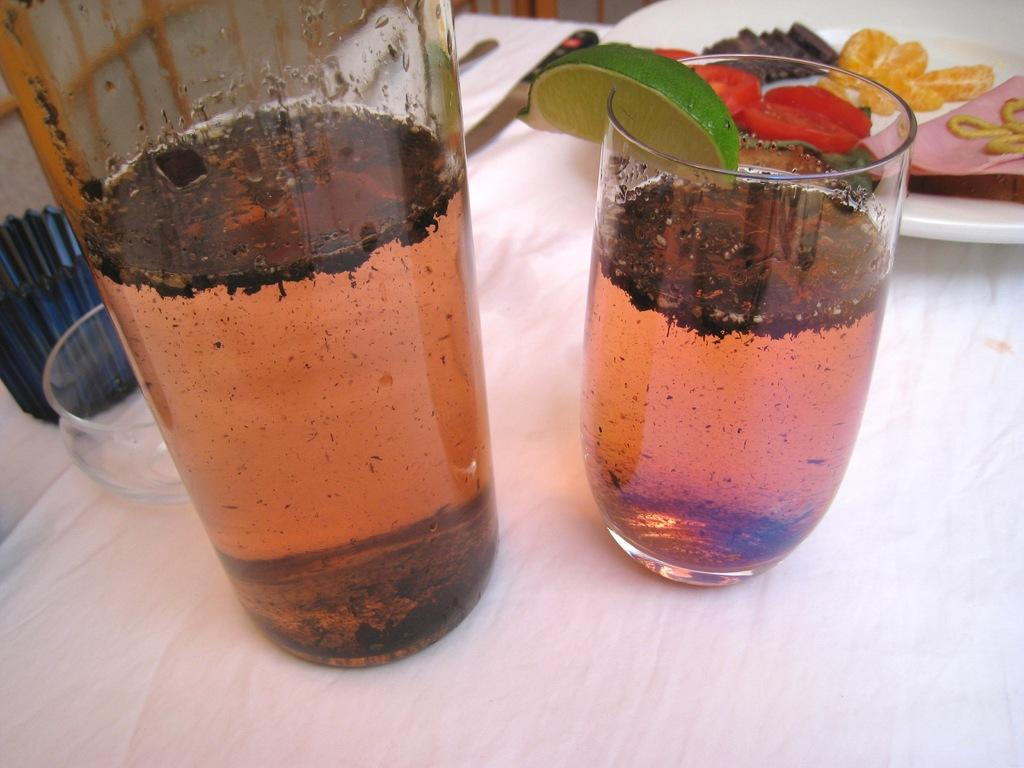What is inside the glasses in the image? There is liquid in the glasses. Are there any additional elements on the glasses? Yes, there is a lemon slice on one of the glasses. What can be seen on a separate object in the image? There are food items on a plate. What can be observed in the background of the image? There are objects visible in the background. Can you hear anyone coughing in the image? There is no audible information in the image, so it is not possible to determine if anyone is coughing. 